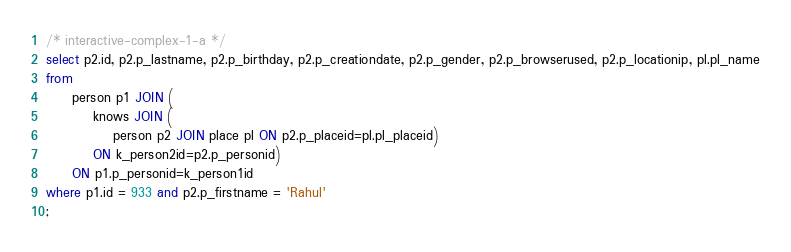Convert code to text. <code><loc_0><loc_0><loc_500><loc_500><_SQL_>/* interactive-complex-1-a */
select p2.id, p2.p_lastname, p2.p_birthday, p2.p_creationdate, p2.p_gender, p2.p_browserused, p2.p_locationip, pl.pl_name
from
     person p1 JOIN (
         knows JOIN (
             person p2 JOIN place pl ON p2.p_placeid=pl.pl_placeid)
         ON k_person2id=p2.p_personid)
     ON p1.p_personid=k_person1id
where p1.id = 933 and p2.p_firstname = 'Rahul'
;
</code> 